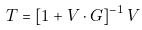Convert formula to latex. <formula><loc_0><loc_0><loc_500><loc_500>T = [ 1 + V \cdot G ] ^ { - 1 } \, V</formula> 